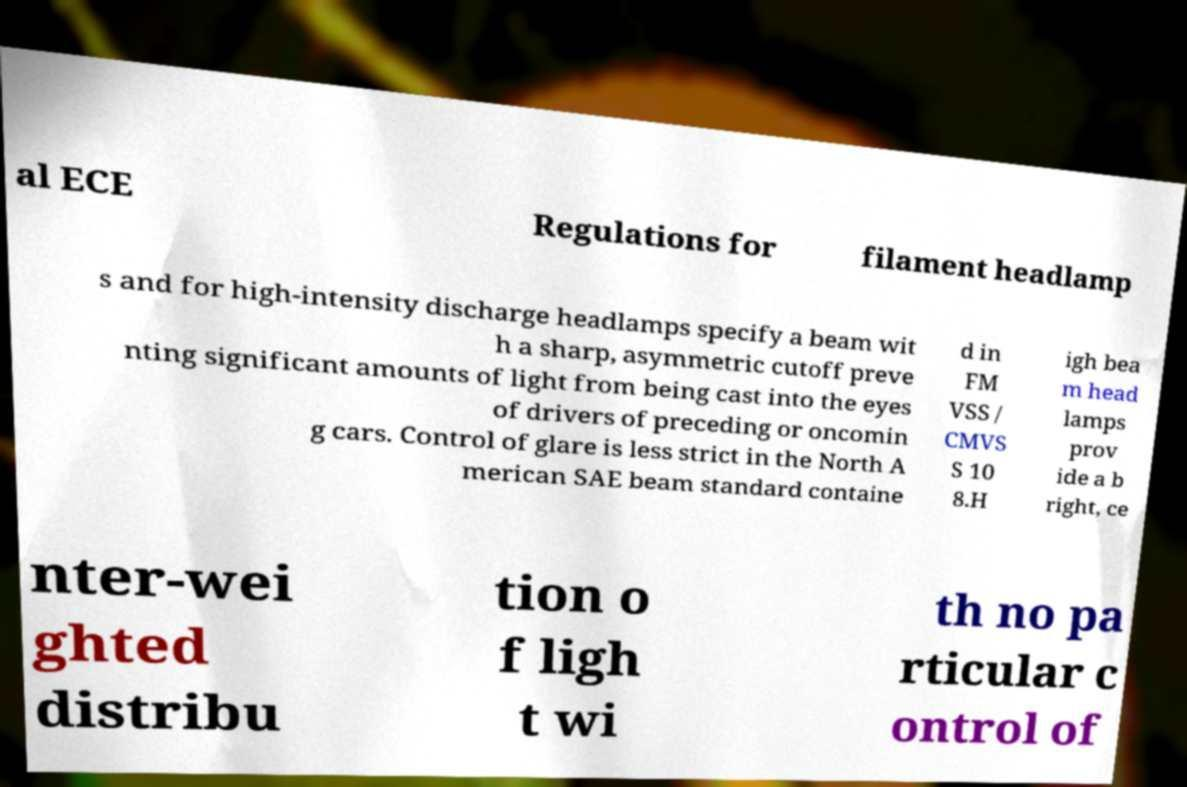What messages or text are displayed in this image? I need them in a readable, typed format. al ECE Regulations for filament headlamp s and for high-intensity discharge headlamps specify a beam wit h a sharp, asymmetric cutoff preve nting significant amounts of light from being cast into the eyes of drivers of preceding or oncomin g cars. Control of glare is less strict in the North A merican SAE beam standard containe d in FM VSS / CMVS S 10 8.H igh bea m head lamps prov ide a b right, ce nter-wei ghted distribu tion o f ligh t wi th no pa rticular c ontrol of 